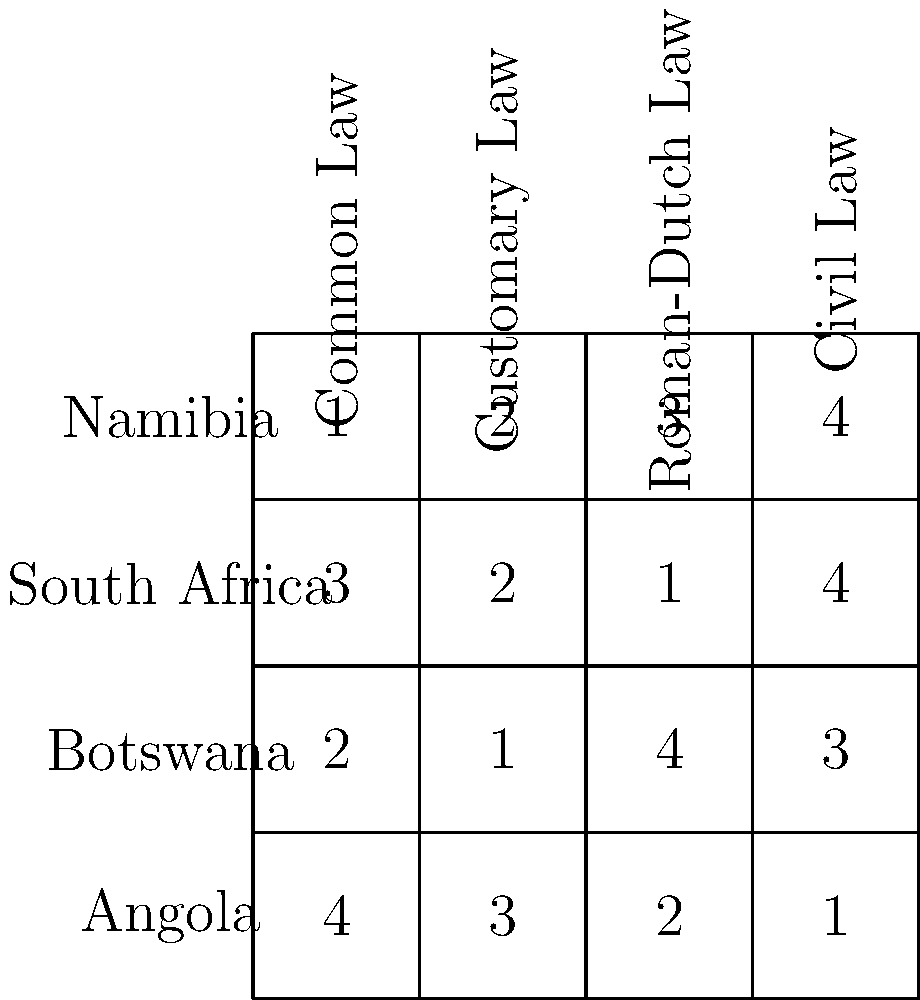Based on the comparative table of legal systems in Namibia and its neighboring countries, which country's legal system relies most heavily on Civil Law? To answer this question, we need to analyze the table provided:

1. The table compares four countries: Namibia, South Africa, Botswana, and Angola.
2. It evaluates four aspects of legal systems: Common Law, Customary Law, Roman-Dutch Law, and Civil Law.
3. The numbers in the table represent the relative importance or influence of each legal aspect in each country's system, with 4 being the highest and 1 being the lowest.
4. We need to focus on the "Civil Law" column to determine which country relies most heavily on it.

Looking at the "Civil Law" column:
- Namibia: 4
- South Africa: 4
- Botswana: 3
- Angola: 1

We can see that both Namibia and South Africa have the highest score (4) for Civil Law. However, the question asks for a single country. In this case, we need to consider the overall legal system composition.

Comparing Namibia and South Africa:
- Namibia: Common Law (1), Customary Law (2), Roman-Dutch Law (3), Civil Law (4)
- South Africa: Common Law (3), Customary Law (2), Roman-Dutch Law (1), Civil Law (4)

Although both countries have the same score for Civil Law, Namibia has lower scores for Common Law and higher scores for Roman-Dutch Law compared to South Africa. This suggests that Namibia relies more heavily on Civil Law in its overall legal system.
Answer: Namibia 